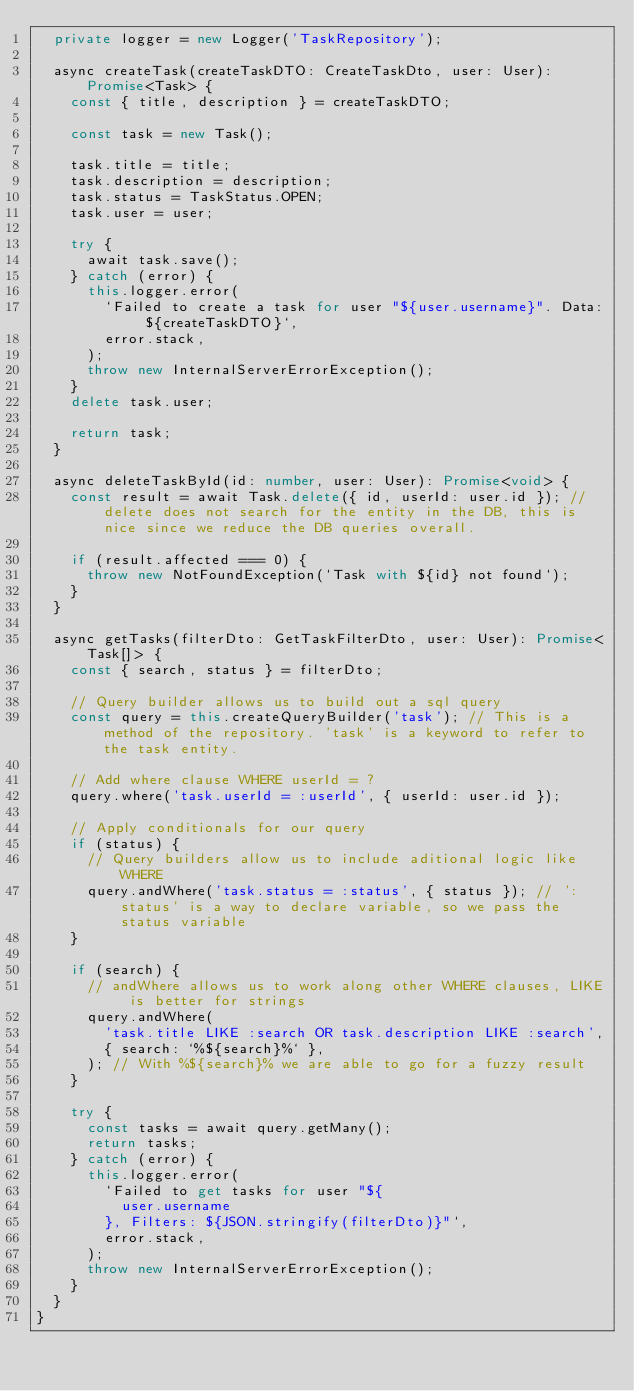<code> <loc_0><loc_0><loc_500><loc_500><_TypeScript_>  private logger = new Logger('TaskRepository');

  async createTask(createTaskDTO: CreateTaskDto, user: User): Promise<Task> {
    const { title, description } = createTaskDTO;

    const task = new Task();

    task.title = title;
    task.description = description;
    task.status = TaskStatus.OPEN;
    task.user = user;

    try {
      await task.save();
    } catch (error) {
      this.logger.error(
        `Failed to create a task for user "${user.username}". Data: ${createTaskDTO}`,
        error.stack,
      );
      throw new InternalServerErrorException();
    }
    delete task.user;

    return task;
  }

  async deleteTaskById(id: number, user: User): Promise<void> {
    const result = await Task.delete({ id, userId: user.id }); // delete does not search for the entity in the DB, this is nice since we reduce the DB queries overall.

    if (result.affected === 0) {
      throw new NotFoundException(`Task with ${id} not found`);
    }
  }

  async getTasks(filterDto: GetTaskFilterDto, user: User): Promise<Task[]> {
    const { search, status } = filterDto;

    // Query builder allows us to build out a sql query
    const query = this.createQueryBuilder('task'); // This is a method of the repository. 'task' is a keyword to refer to the task entity.

    // Add where clause WHERE userId = ?
    query.where('task.userId = :userId', { userId: user.id });

    // Apply conditionals for our query
    if (status) {
      // Query builders allow us to include aditional logic like WHERE
      query.andWhere('task.status = :status', { status }); // ':status' is a way to declare variable, so we pass the status variable
    }

    if (search) {
      // andWhere allows us to work along other WHERE clauses, LIKE is better for strings
      query.andWhere(
        'task.title LIKE :search OR task.description LIKE :search',
        { search: `%${search}%` },
      ); // With %${search}% we are able to go for a fuzzy result
    }

    try {
      const tasks = await query.getMany();
      return tasks;
    } catch (error) {
      this.logger.error(
        `Failed to get tasks for user "${
          user.username
        }, Filters: ${JSON.stringify(filterDto)}"`,
        error.stack,
      );
      throw new InternalServerErrorException();
    }
  }
}
</code> 